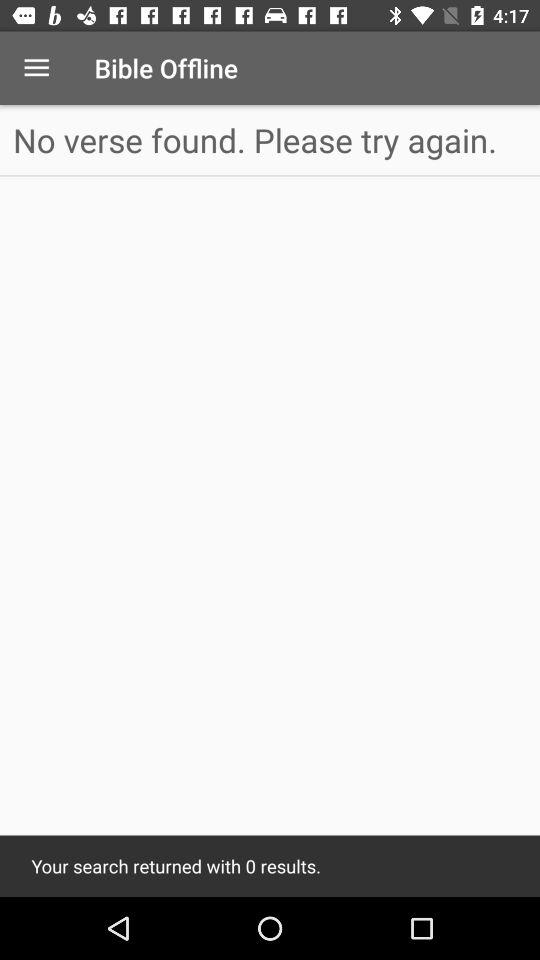How many results did the search return?
Answer the question using a single word or phrase. 0 